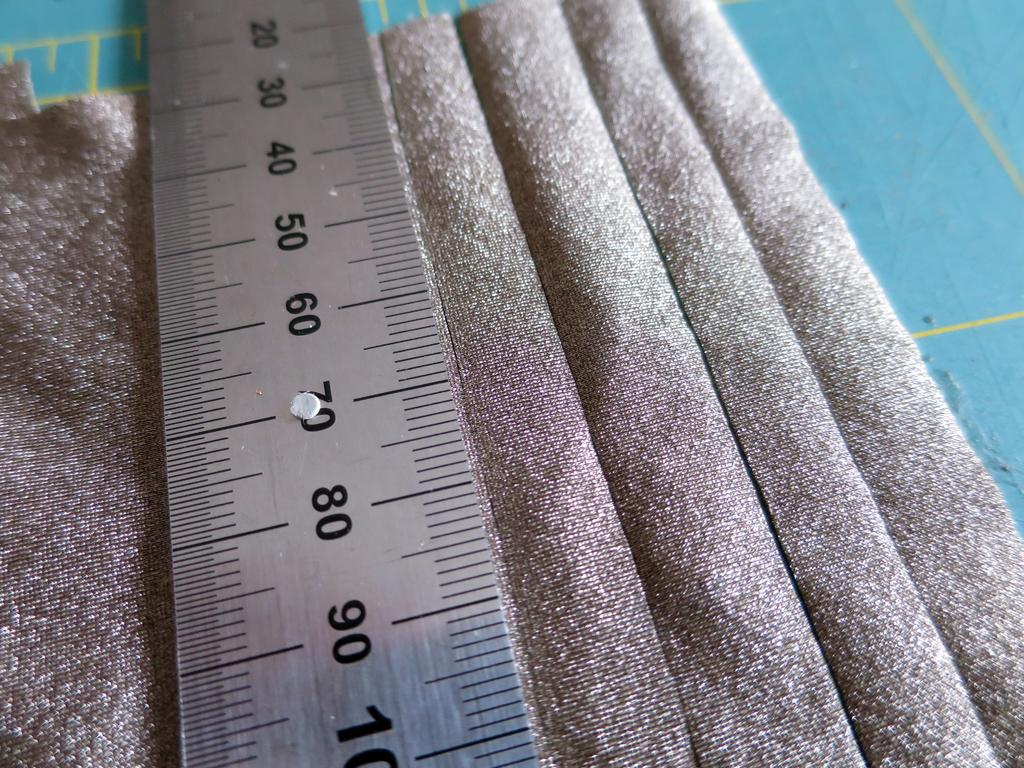<image>
Share a concise interpretation of the image provided. A metal with the numbers 20, 30, 40, 50, 60, 70, 80, and 90 is on top of silver fabric. 